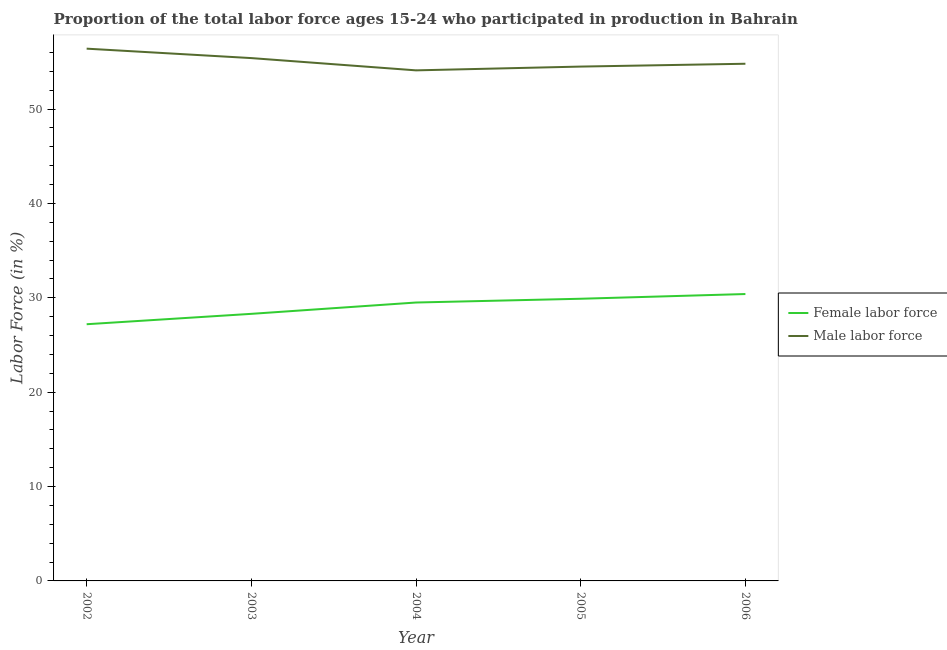Is the number of lines equal to the number of legend labels?
Provide a succinct answer. Yes. What is the percentage of female labor force in 2003?
Your answer should be compact. 28.3. Across all years, what is the maximum percentage of male labour force?
Provide a short and direct response. 56.4. Across all years, what is the minimum percentage of female labor force?
Provide a short and direct response. 27.2. In which year was the percentage of female labor force minimum?
Keep it short and to the point. 2002. What is the total percentage of male labour force in the graph?
Make the answer very short. 275.2. What is the difference between the percentage of female labor force in 2002 and that in 2003?
Make the answer very short. -1.1. What is the difference between the percentage of male labour force in 2005 and the percentage of female labor force in 2003?
Provide a short and direct response. 26.2. What is the average percentage of male labour force per year?
Make the answer very short. 55.04. In the year 2002, what is the difference between the percentage of male labour force and percentage of female labor force?
Provide a succinct answer. 29.2. In how many years, is the percentage of female labor force greater than 26 %?
Give a very brief answer. 5. What is the ratio of the percentage of female labor force in 2003 to that in 2004?
Your answer should be compact. 0.96. Is the percentage of female labor force in 2002 less than that in 2005?
Offer a terse response. Yes. Is the difference between the percentage of female labor force in 2003 and 2005 greater than the difference between the percentage of male labour force in 2003 and 2005?
Offer a terse response. No. What is the difference between the highest and the lowest percentage of male labour force?
Give a very brief answer. 2.3. In how many years, is the percentage of male labour force greater than the average percentage of male labour force taken over all years?
Keep it short and to the point. 2. Is the percentage of female labor force strictly greater than the percentage of male labour force over the years?
Provide a succinct answer. No. How many lines are there?
Give a very brief answer. 2. How many years are there in the graph?
Ensure brevity in your answer.  5. What is the difference between two consecutive major ticks on the Y-axis?
Provide a succinct answer. 10. Are the values on the major ticks of Y-axis written in scientific E-notation?
Your response must be concise. No. Does the graph contain grids?
Offer a very short reply. No. How many legend labels are there?
Your response must be concise. 2. What is the title of the graph?
Provide a short and direct response. Proportion of the total labor force ages 15-24 who participated in production in Bahrain. What is the Labor Force (in %) of Female labor force in 2002?
Provide a succinct answer. 27.2. What is the Labor Force (in %) in Male labor force in 2002?
Offer a terse response. 56.4. What is the Labor Force (in %) of Female labor force in 2003?
Your response must be concise. 28.3. What is the Labor Force (in %) of Male labor force in 2003?
Your answer should be compact. 55.4. What is the Labor Force (in %) of Female labor force in 2004?
Provide a short and direct response. 29.5. What is the Labor Force (in %) of Male labor force in 2004?
Ensure brevity in your answer.  54.1. What is the Labor Force (in %) in Female labor force in 2005?
Give a very brief answer. 29.9. What is the Labor Force (in %) in Male labor force in 2005?
Provide a short and direct response. 54.5. What is the Labor Force (in %) in Female labor force in 2006?
Offer a very short reply. 30.4. What is the Labor Force (in %) of Male labor force in 2006?
Provide a short and direct response. 54.8. Across all years, what is the maximum Labor Force (in %) in Female labor force?
Your response must be concise. 30.4. Across all years, what is the maximum Labor Force (in %) of Male labor force?
Your response must be concise. 56.4. Across all years, what is the minimum Labor Force (in %) of Female labor force?
Your response must be concise. 27.2. Across all years, what is the minimum Labor Force (in %) in Male labor force?
Give a very brief answer. 54.1. What is the total Labor Force (in %) of Female labor force in the graph?
Offer a very short reply. 145.3. What is the total Labor Force (in %) in Male labor force in the graph?
Provide a short and direct response. 275.2. What is the difference between the Labor Force (in %) in Female labor force in 2002 and that in 2003?
Provide a short and direct response. -1.1. What is the difference between the Labor Force (in %) in Female labor force in 2002 and that in 2004?
Provide a succinct answer. -2.3. What is the difference between the Labor Force (in %) of Female labor force in 2002 and that in 2005?
Your response must be concise. -2.7. What is the difference between the Labor Force (in %) of Female labor force in 2002 and that in 2006?
Your answer should be compact. -3.2. What is the difference between the Labor Force (in %) in Male labor force in 2002 and that in 2006?
Offer a terse response. 1.6. What is the difference between the Labor Force (in %) of Male labor force in 2003 and that in 2005?
Provide a short and direct response. 0.9. What is the difference between the Labor Force (in %) of Male labor force in 2004 and that in 2005?
Your response must be concise. -0.4. What is the difference between the Labor Force (in %) of Female labor force in 2004 and that in 2006?
Offer a very short reply. -0.9. What is the difference between the Labor Force (in %) of Female labor force in 2005 and that in 2006?
Offer a terse response. -0.5. What is the difference between the Labor Force (in %) in Male labor force in 2005 and that in 2006?
Offer a very short reply. -0.3. What is the difference between the Labor Force (in %) in Female labor force in 2002 and the Labor Force (in %) in Male labor force in 2003?
Ensure brevity in your answer.  -28.2. What is the difference between the Labor Force (in %) in Female labor force in 2002 and the Labor Force (in %) in Male labor force in 2004?
Your answer should be very brief. -26.9. What is the difference between the Labor Force (in %) in Female labor force in 2002 and the Labor Force (in %) in Male labor force in 2005?
Offer a terse response. -27.3. What is the difference between the Labor Force (in %) in Female labor force in 2002 and the Labor Force (in %) in Male labor force in 2006?
Your response must be concise. -27.6. What is the difference between the Labor Force (in %) of Female labor force in 2003 and the Labor Force (in %) of Male labor force in 2004?
Offer a terse response. -25.8. What is the difference between the Labor Force (in %) of Female labor force in 2003 and the Labor Force (in %) of Male labor force in 2005?
Your response must be concise. -26.2. What is the difference between the Labor Force (in %) in Female labor force in 2003 and the Labor Force (in %) in Male labor force in 2006?
Provide a succinct answer. -26.5. What is the difference between the Labor Force (in %) of Female labor force in 2004 and the Labor Force (in %) of Male labor force in 2006?
Keep it short and to the point. -25.3. What is the difference between the Labor Force (in %) of Female labor force in 2005 and the Labor Force (in %) of Male labor force in 2006?
Ensure brevity in your answer.  -24.9. What is the average Labor Force (in %) in Female labor force per year?
Offer a terse response. 29.06. What is the average Labor Force (in %) of Male labor force per year?
Offer a very short reply. 55.04. In the year 2002, what is the difference between the Labor Force (in %) of Female labor force and Labor Force (in %) of Male labor force?
Provide a short and direct response. -29.2. In the year 2003, what is the difference between the Labor Force (in %) in Female labor force and Labor Force (in %) in Male labor force?
Your answer should be compact. -27.1. In the year 2004, what is the difference between the Labor Force (in %) of Female labor force and Labor Force (in %) of Male labor force?
Make the answer very short. -24.6. In the year 2005, what is the difference between the Labor Force (in %) in Female labor force and Labor Force (in %) in Male labor force?
Your answer should be very brief. -24.6. In the year 2006, what is the difference between the Labor Force (in %) of Female labor force and Labor Force (in %) of Male labor force?
Provide a succinct answer. -24.4. What is the ratio of the Labor Force (in %) in Female labor force in 2002 to that in 2003?
Your response must be concise. 0.96. What is the ratio of the Labor Force (in %) of Male labor force in 2002 to that in 2003?
Offer a very short reply. 1.02. What is the ratio of the Labor Force (in %) in Female labor force in 2002 to that in 2004?
Ensure brevity in your answer.  0.92. What is the ratio of the Labor Force (in %) of Male labor force in 2002 to that in 2004?
Your answer should be compact. 1.04. What is the ratio of the Labor Force (in %) of Female labor force in 2002 to that in 2005?
Your response must be concise. 0.91. What is the ratio of the Labor Force (in %) in Male labor force in 2002 to that in 2005?
Your response must be concise. 1.03. What is the ratio of the Labor Force (in %) in Female labor force in 2002 to that in 2006?
Offer a terse response. 0.89. What is the ratio of the Labor Force (in %) in Male labor force in 2002 to that in 2006?
Provide a succinct answer. 1.03. What is the ratio of the Labor Force (in %) in Female labor force in 2003 to that in 2004?
Provide a succinct answer. 0.96. What is the ratio of the Labor Force (in %) of Female labor force in 2003 to that in 2005?
Keep it short and to the point. 0.95. What is the ratio of the Labor Force (in %) in Male labor force in 2003 to that in 2005?
Your response must be concise. 1.02. What is the ratio of the Labor Force (in %) of Female labor force in 2003 to that in 2006?
Give a very brief answer. 0.93. What is the ratio of the Labor Force (in %) of Male labor force in 2003 to that in 2006?
Your answer should be very brief. 1.01. What is the ratio of the Labor Force (in %) of Female labor force in 2004 to that in 2005?
Offer a very short reply. 0.99. What is the ratio of the Labor Force (in %) in Female labor force in 2004 to that in 2006?
Offer a terse response. 0.97. What is the ratio of the Labor Force (in %) of Male labor force in 2004 to that in 2006?
Ensure brevity in your answer.  0.99. What is the ratio of the Labor Force (in %) of Female labor force in 2005 to that in 2006?
Give a very brief answer. 0.98. What is the difference between the highest and the second highest Labor Force (in %) in Female labor force?
Provide a short and direct response. 0.5. What is the difference between the highest and the second highest Labor Force (in %) of Male labor force?
Provide a short and direct response. 1. What is the difference between the highest and the lowest Labor Force (in %) in Female labor force?
Your answer should be compact. 3.2. 